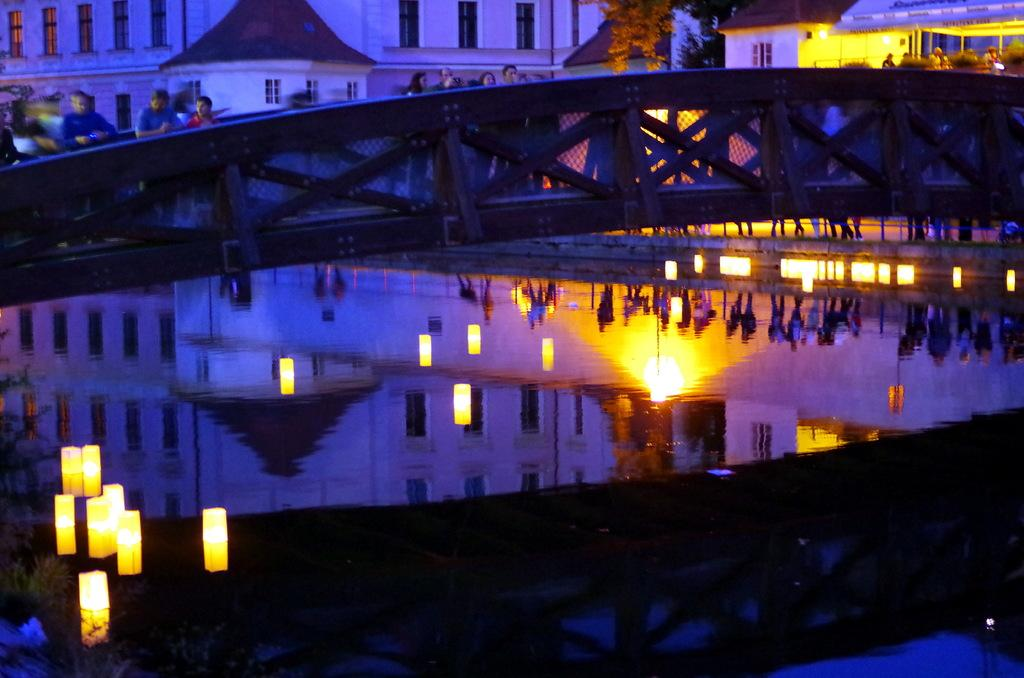What is the main feature of the image? There is water in the image. What structure can be seen crossing the water? There is a bridge in the image. What are the people in the image doing? People are standing on the bridge. What can be seen in the distance behind the bridge? There are buildings visible in the background of the image. What type of apparatus is being used by the people on the bridge to communicate in a foreign language? There is no apparatus or foreign language mentioned in the image; people are simply standing on the bridge. 